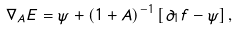<formula> <loc_0><loc_0><loc_500><loc_500>\nabla _ { A } E = \psi + ( 1 + A ) ^ { - 1 } \left [ \partial _ { 1 } f - \psi \right ] ,</formula> 